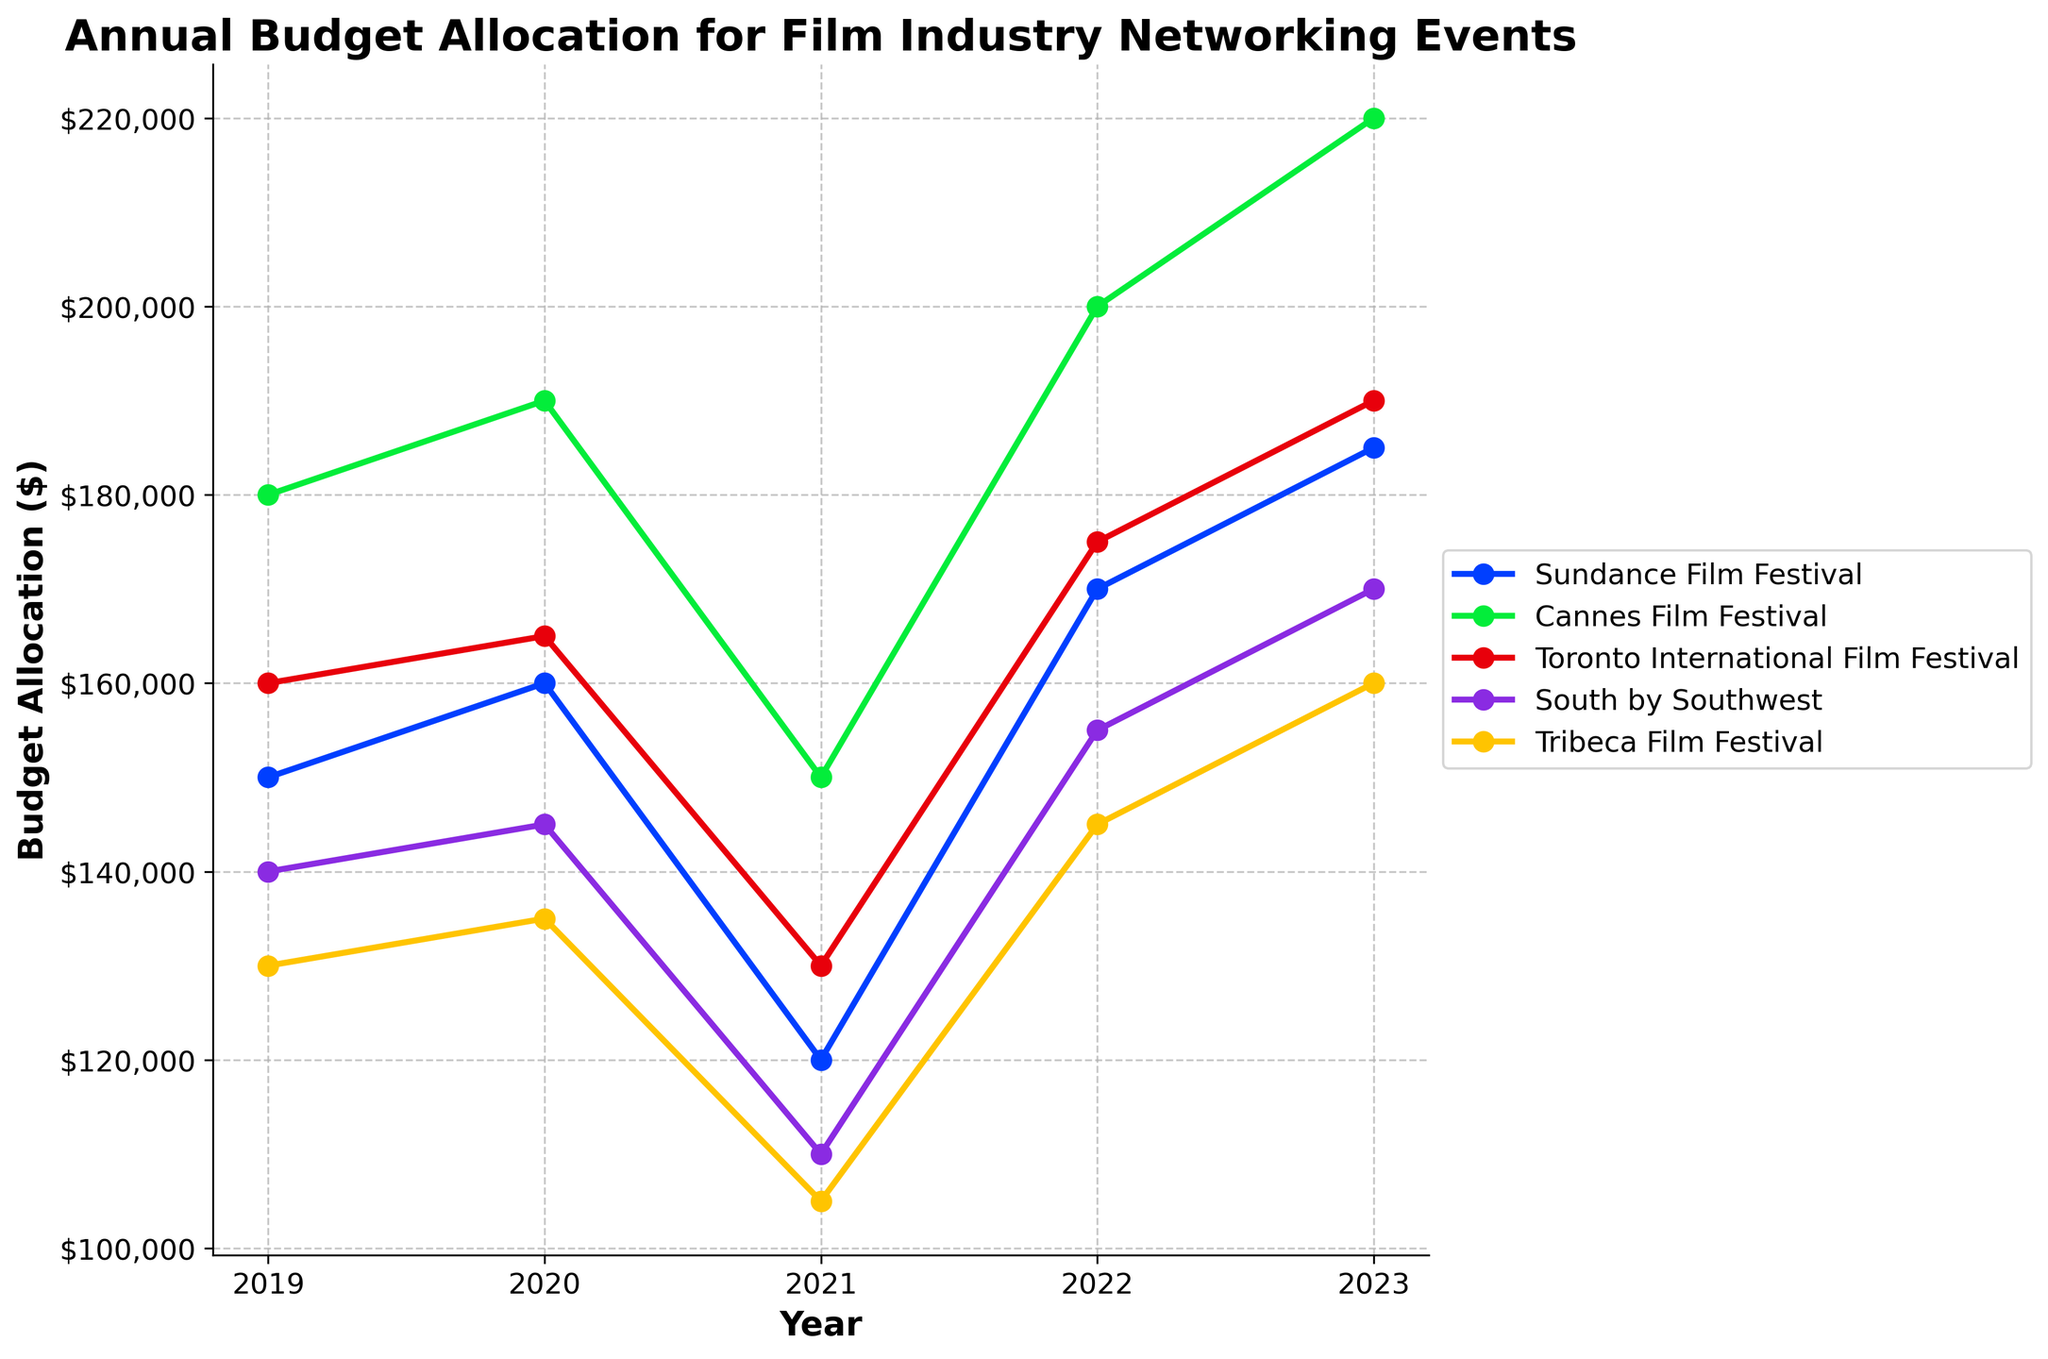Is there a year where the budget allocation for the Toronto International Film Festival decreased? If so, which year? Check the line corresponding to the Toronto International Film Festival and observe its trend. From 2020 to 2021, the budget decreases from $165,000 to $130,000 for the Toronto International Film Festival.
Answer: 2021 Which festival had the highest budget allocation in 2023? Look at the end of each line (2023) and find the highest point. The Cannes Film Festival has the highest budget in 2023, with $220,000.
Answer: Cannes Film Festival What is the average budget allocation of Sundance Film Festival from 2019 to 2023? Sum the annual budget allocations for Sundance (150,000 + 160,000 + 120,000 + 170,000 + 185,000) and divide by the number of years (5). The calculation is (150,000 + 160,000 + 120,000 + 170,000 + 185,000) / 5 = 157,000.
Answer: $157,000 Which festival had the least budget allocation in 2021? Check the values for each festival in 2021. The Tribeca Film Festival had the lowest budget allocation at $105,000 in 2021.
Answer: Tribeca Film Festival Between 2021 and 2022, which festival showed the largest increase in budget allocation, and by how much? Calculate the difference between the budgets for each festival from 2021 to 2022 and identify the largest increase. Increases: Sundance (50,000), Cannes (50,000), Toronto (45,000), South by Southwest (45,000), Tribeca (40,000). The largest increase is for Cannes and Sundance at $50,000.
Answer: Cannes Film Festival and Sundance Film Festival, $50,000 Ignoring 2021, which saw a general decrease, what is the overall trend in budget allocation for the South by Southwest from 2019 to 2023? Observe the trend of South by Southwest's line from 2019 to 2020, 2022, and 2023. The budget generally increases from $140,000 in 2019 to $170,000 in 2023.
Answer: Increasing Across all festivals, how many times did the budget allocation decrease from one year to the next? Visually inspect each line to count the decreases. Sundance (2019-2020: no, 2020-2021: yes), Cannes (2019-2020: no, 2020-2021: yes), Toronto (2019-2020: no, 2020-2021: yes), South by Southwest (2019-2020: no, 2020-2021: yes), Tribeca (2019-2020: no, 2020-2021: yes). There are 5 decreases.
Answer: 5 If you combine the budget allocations of all five festivals in 2020, what is the total? Add the annual budget allocations of all festivals in 2020: (160,000 + 190,000 + 165,000 + 145,000 + 135,000). The total is 160,000 + 190,000 + 165,000 + 145,000 + 135,000 = 795,000.
Answer: $795,000 Which years had the Tribeca Film Festival maintaining the same budget since the previous year? Look for years where the line for Tribeca Film Festival runs horizontally or is very close for consecutive years. From 2019 to 2020 and from 2022 to 2023, the budgets (130,000 to 135,000 and 145,000 to 160,000, respectively) vary enough to note changes every consecutive year, with no exact repeat budget.
Answer: None Among all the festivals, which one had the smallest budget "recover" (increase) from 2021 to 2023? Calculate the increase from 2021 to 2023 for all festivals: Sundance (65,000), Cannes (70,000), Toronto (60,000), South by Southwest (60,000), Tribeca (55,000). The smallest increase is Tribeca with $55,000.
Answer: Tribeca Film Festival 